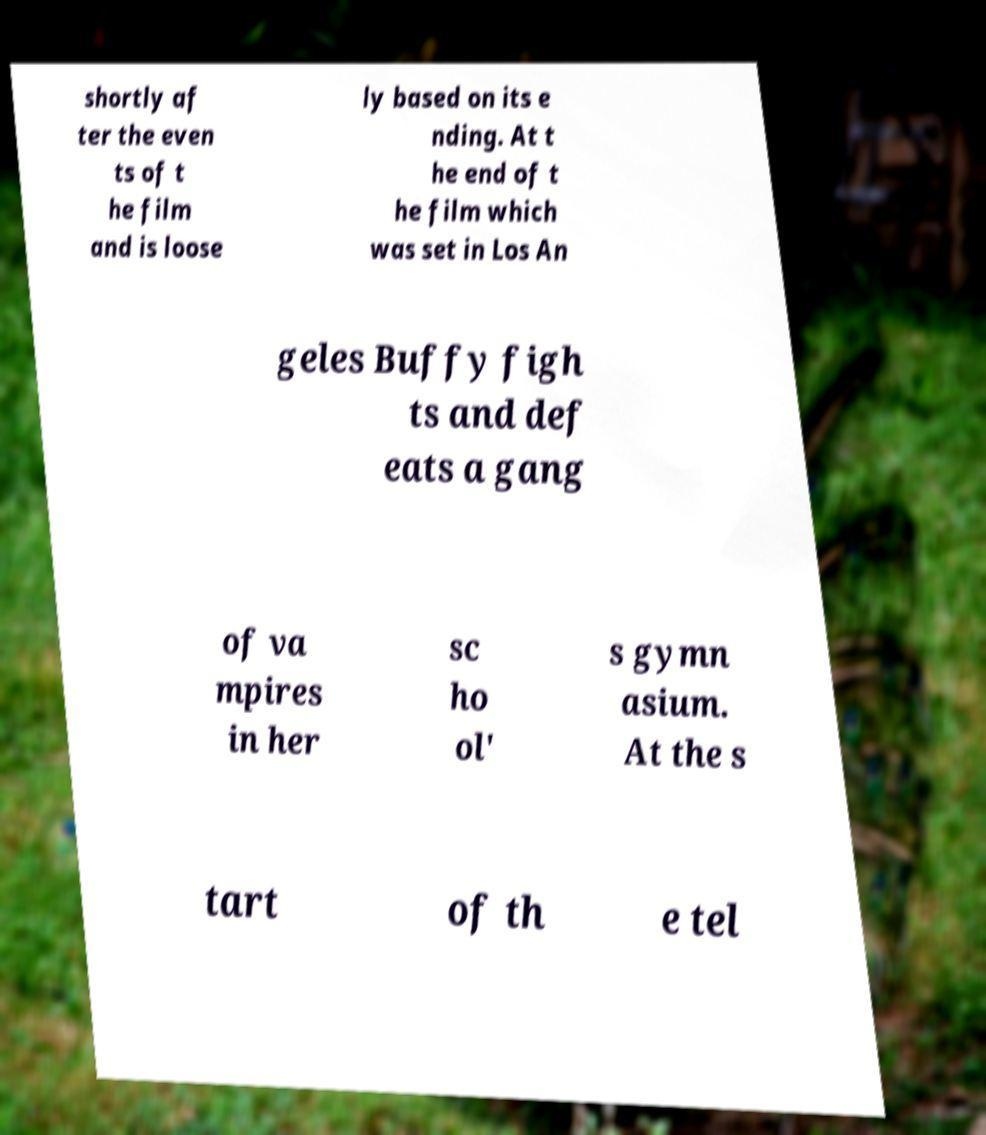Please identify and transcribe the text found in this image. shortly af ter the even ts of t he film and is loose ly based on its e nding. At t he end of t he film which was set in Los An geles Buffy figh ts and def eats a gang of va mpires in her sc ho ol' s gymn asium. At the s tart of th e tel 